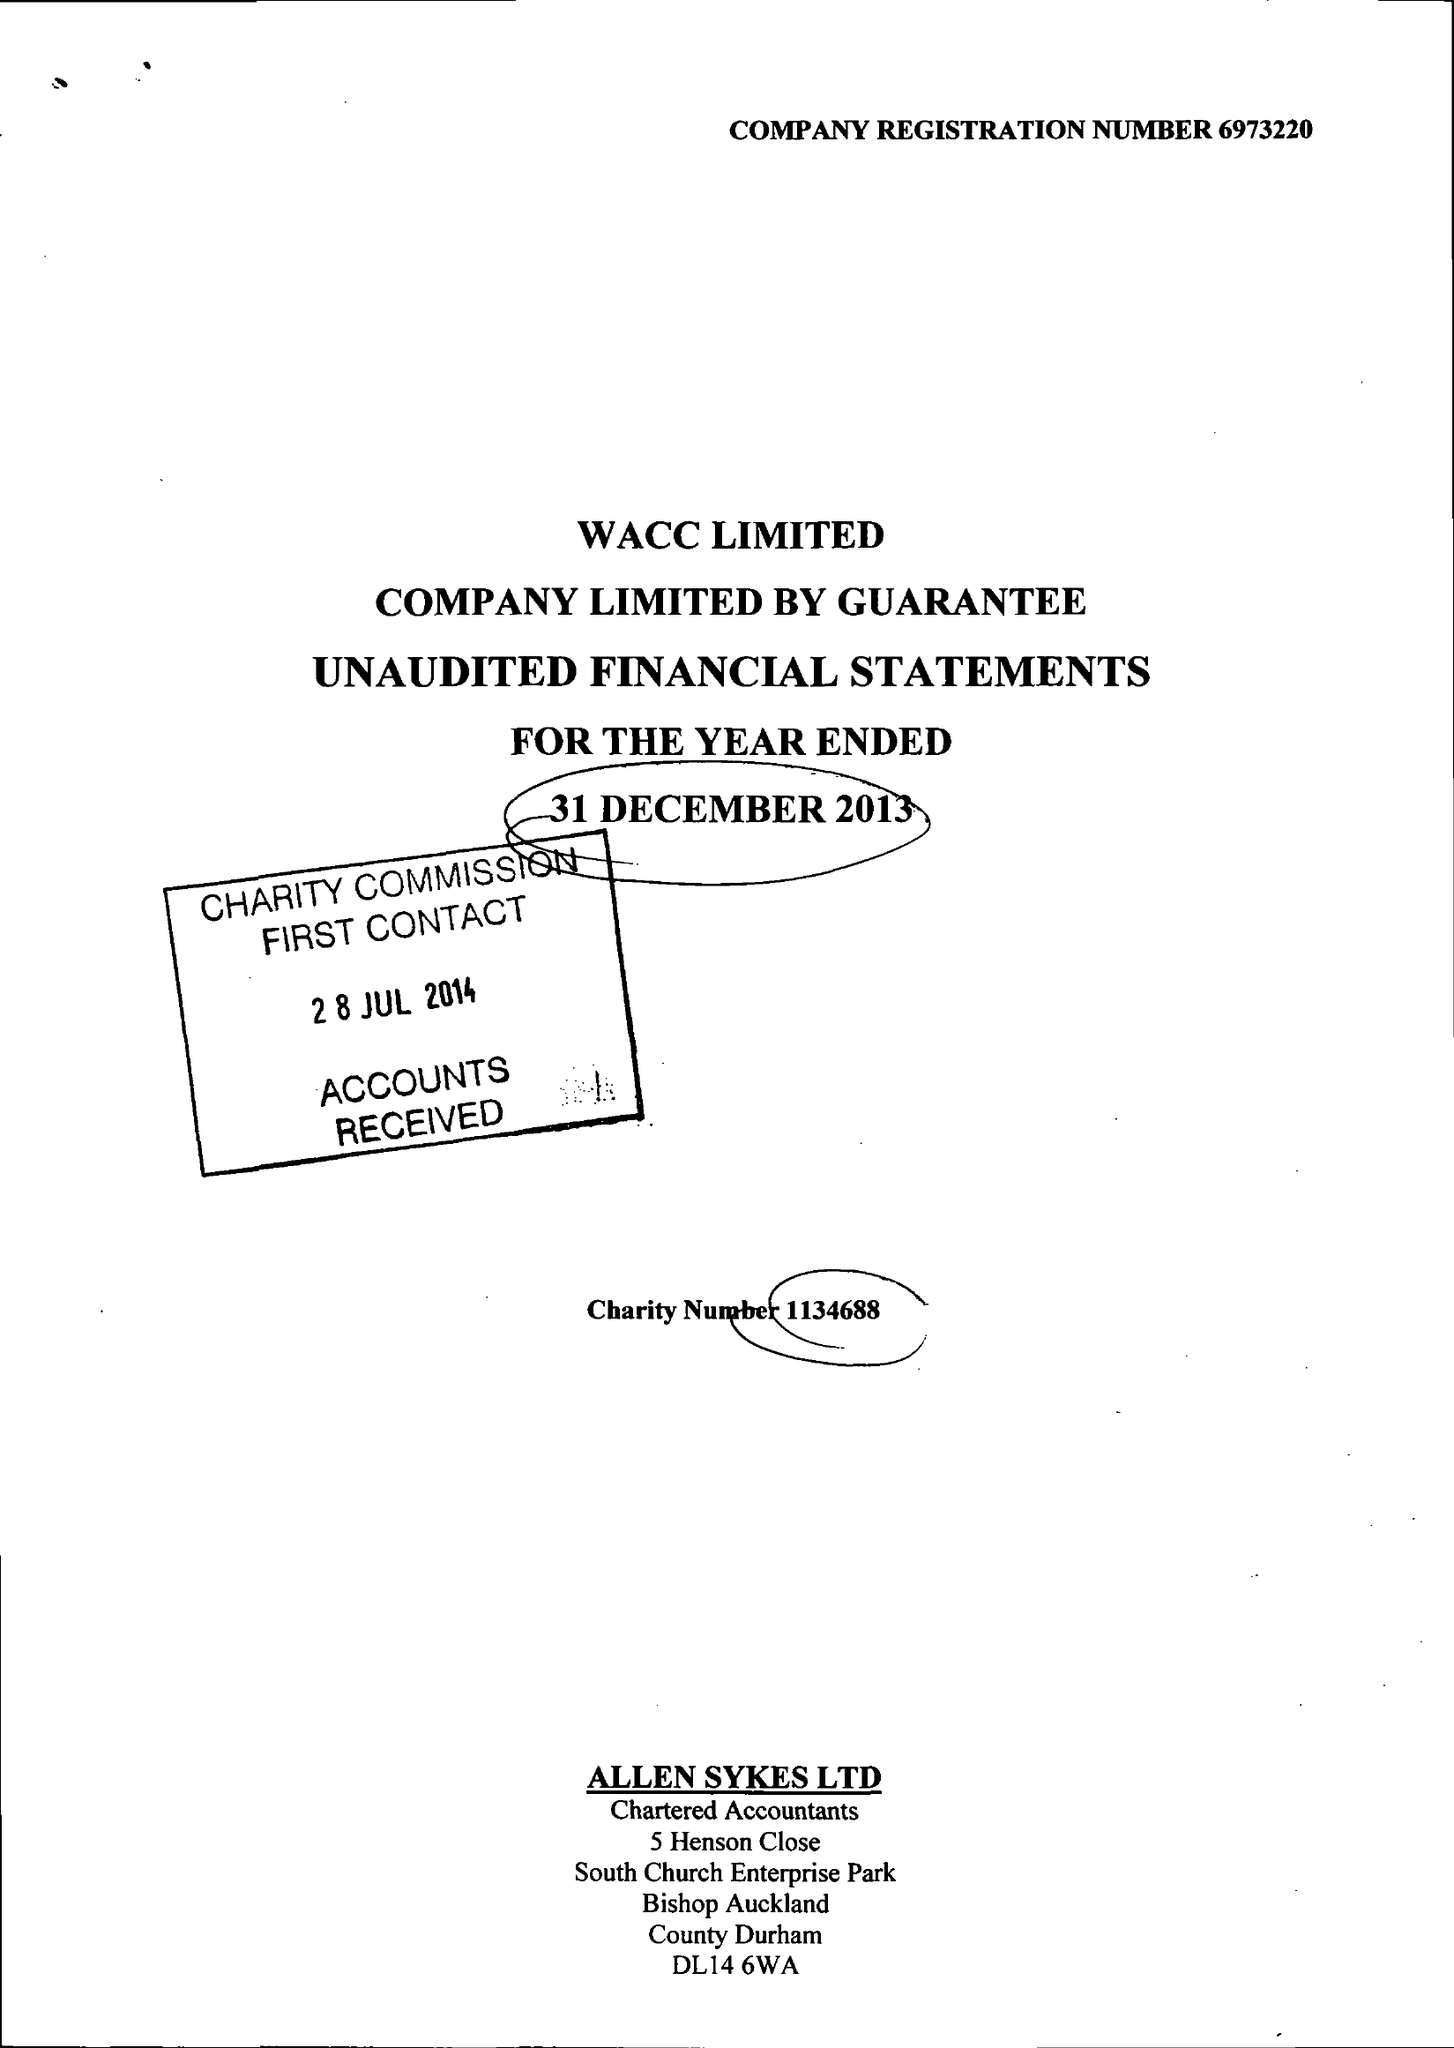What is the value for the charity_number?
Answer the question using a single word or phrase. 1134688 